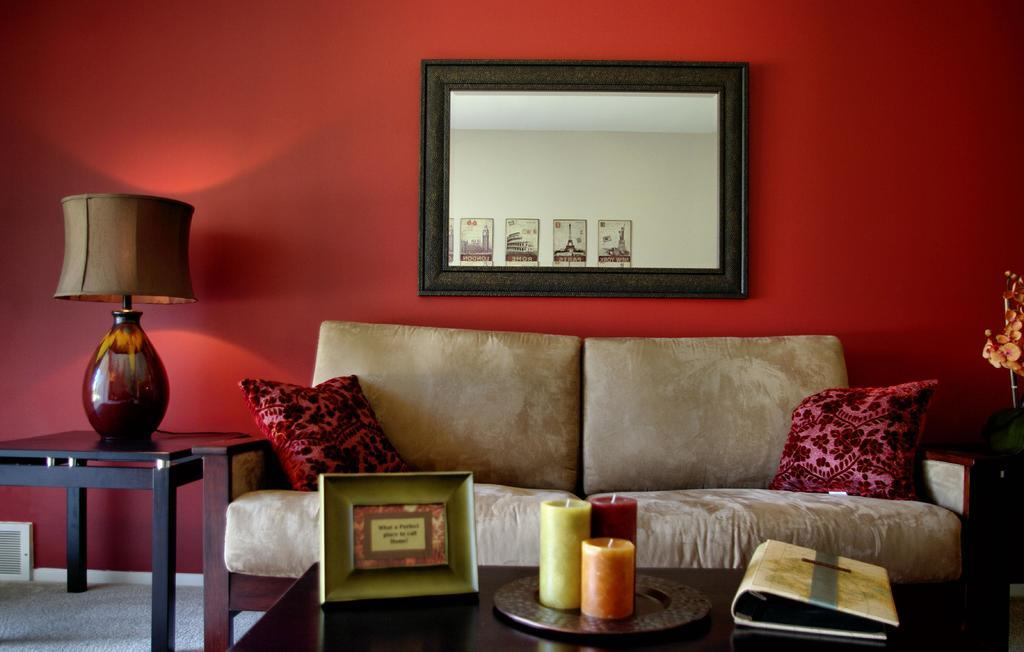What piece of furniture is located in the middle of the image? There is a sofa in the middle of the image. What can be seen behind the sofa in the image? There is a wall behind the sofa in the image. What type of apparel is being worn by the sofa in the image? The sofa is not a person and does not wear apparel; it is a piece of furniture. 